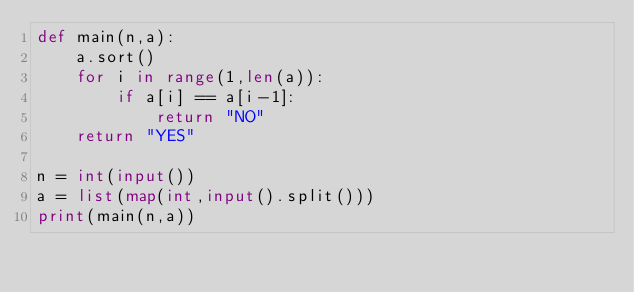Convert code to text. <code><loc_0><loc_0><loc_500><loc_500><_Python_>def main(n,a):
    a.sort()
    for i in range(1,len(a)):
        if a[i] == a[i-1]:
            return "NO"
    return "YES"

n = int(input())
a = list(map(int,input().split()))
print(main(n,a))</code> 